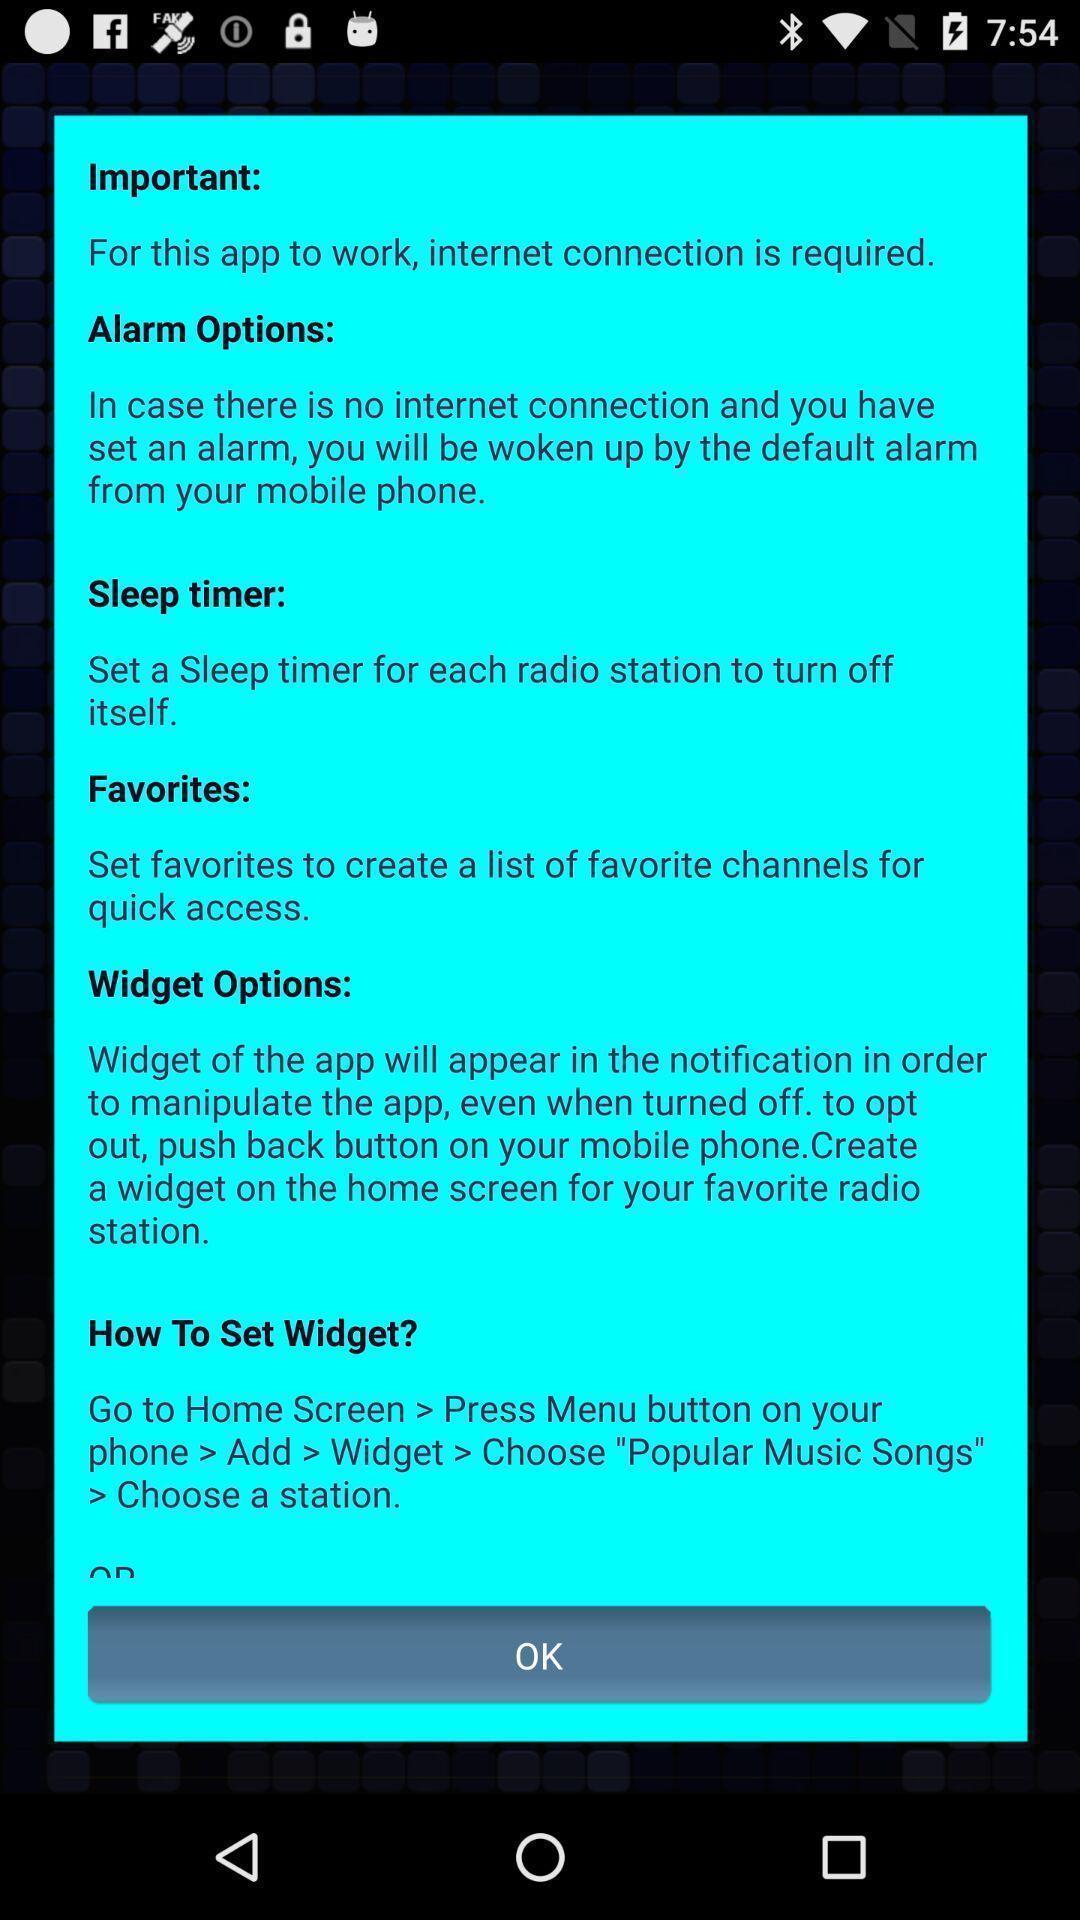Give me a summary of this screen capture. Pop up showing information about an app. 